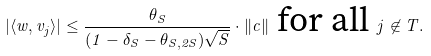Convert formula to latex. <formula><loc_0><loc_0><loc_500><loc_500>| \langle w , v _ { j } \rangle | \leq \frac { \theta _ { S } } { ( 1 - \delta _ { S } - \theta _ { S , 2 S } ) \sqrt { S } } \cdot \| c \| \text { for all } j \not \in T .</formula> 